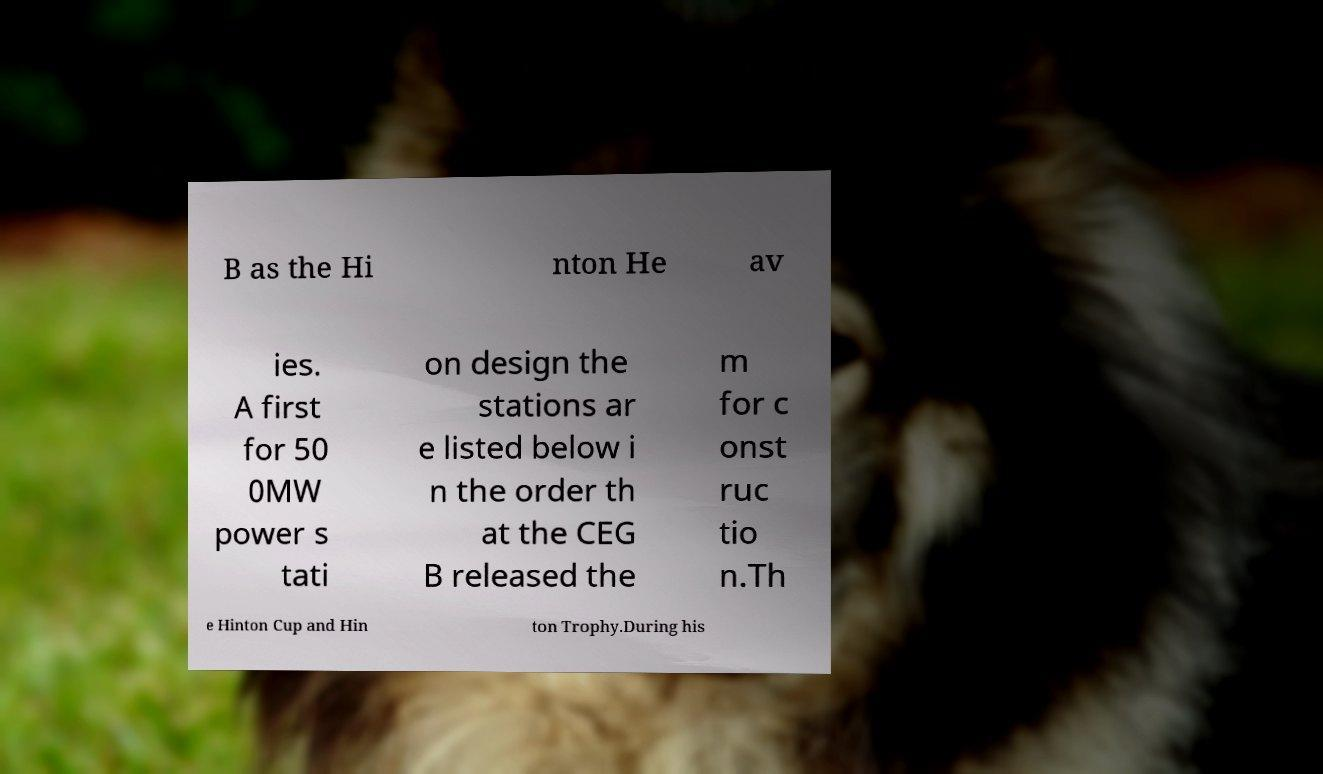Could you extract and type out the text from this image? B as the Hi nton He av ies. A first for 50 0MW power s tati on design the stations ar e listed below i n the order th at the CEG B released the m for c onst ruc tio n.Th e Hinton Cup and Hin ton Trophy.During his 